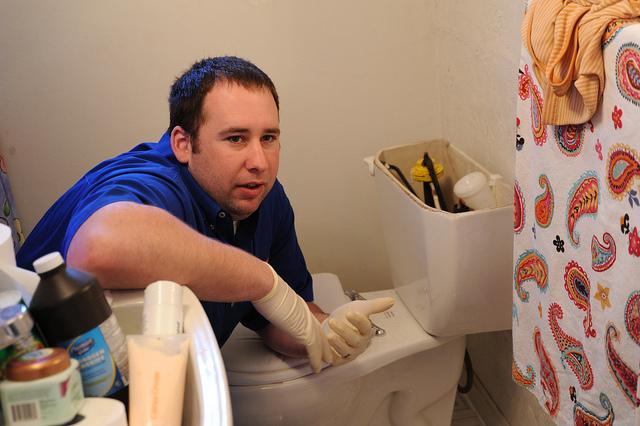Is he a maid?
Give a very brief answer. No. What is he repairing?
Concise answer only. Toilet. What is on his hands?
Write a very short answer. Gloves. 